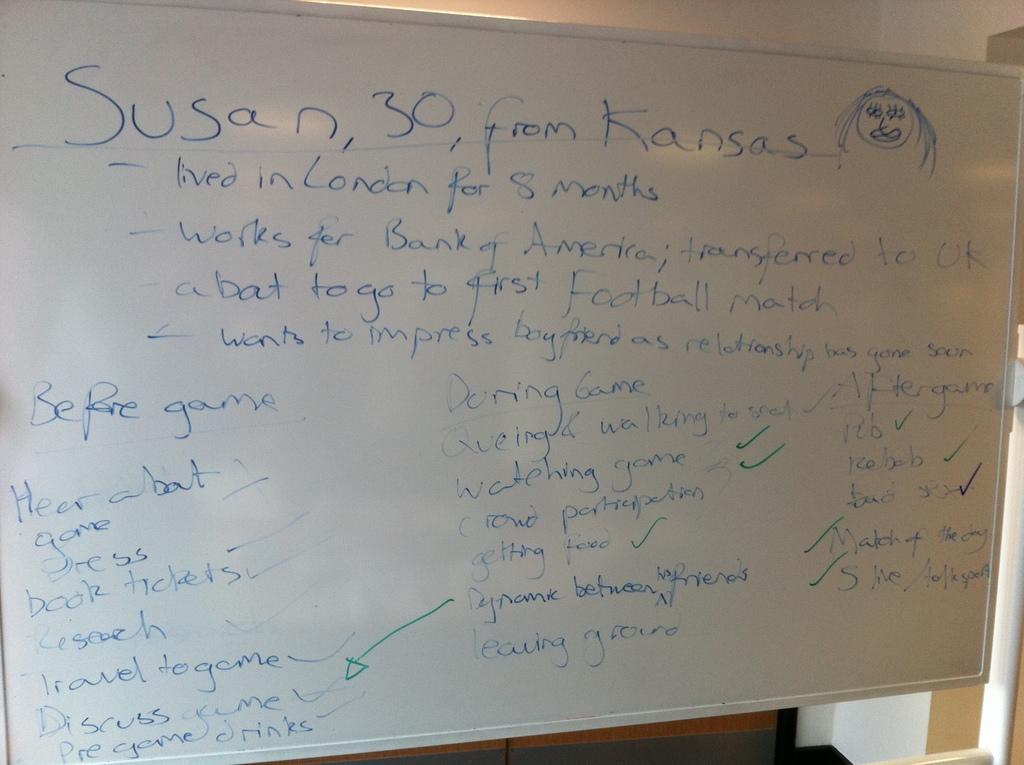Where is susan from?
Your answer should be very brief. Kansas. How old is susan?
Offer a very short reply. 30. 